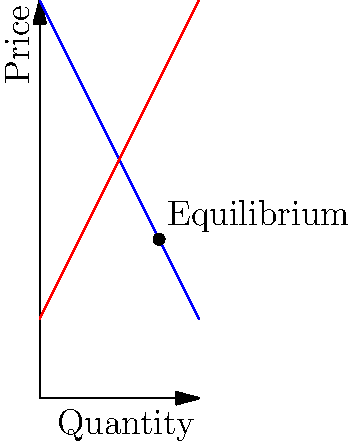As a marketing specialist, you're analyzing the elasticity of demand for a new product launch. Given the supply and demand curves in the graph, where the demand function is $P = 100 - 2Q$ and the supply function is $P = 2Q + 20$, calculate the point elasticity of demand at the equilibrium point. How would this elasticity impact your marketing strategy for the product launch? To solve this problem, we'll follow these steps:

1. Find the equilibrium point:
   Set demand equal to supply: $100 - 2Q = 2Q + 20$
   Solve for Q: $80 = 4Q$, so $Q = 20$
   Substitute back to find P: $P = 100 - 2(20) = 60$
   Equilibrium point: $(20, 60)$

2. Calculate the point elasticity of demand:
   The formula for point elasticity is: $E_d = -\frac{dP}{dQ} \cdot \frac{Q}{P}$

   a) Find $\frac{dP}{dQ}$:
      From the demand function, $P = 100 - 2Q$
      $\frac{dP}{dQ} = -2$

   b) Substitute into the elasticity formula:
      $E_d = -(-2) \cdot \frac{20}{60} = \frac{2}{3} \approx 0.67$

3. Interpret the result:
   The elasticity is less than 1, indicating that demand is inelastic at the equilibrium point. This means that a change in price will result in a proportionally smaller change in quantity demanded.

4. Marketing strategy implications:
   - Price changes will have a relatively small impact on demand, so aggressive price cuts may not significantly boost sales.
   - Focus on non-price factors like product features, quality, and brand image to differentiate the product.
   - Emphasize the unique value proposition of the product to justify its price point.
   - Consider bundling or value-added services to increase perceived value without directly lowering the price.
   - Target marketing efforts towards less price-sensitive customer segments.
Answer: $E_d = \frac{2}{3}$ (inelastic); focus on non-price factors and value proposition in marketing strategy. 